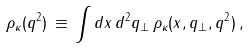<formula> <loc_0><loc_0><loc_500><loc_500>\rho _ { \kappa } ( q ^ { 2 } ) \, \equiv \, \int d x \, d ^ { 2 } q _ { \perp } \, \rho _ { \kappa } ( x , { q } _ { \perp } , q ^ { 2 } ) \, ,</formula> 